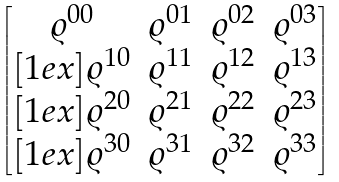<formula> <loc_0><loc_0><loc_500><loc_500>\begin{bmatrix} \varrho ^ { 0 0 } & \varrho ^ { 0 1 } & \varrho ^ { 0 2 } & \varrho ^ { 0 3 } \\ [ 1 e x ] \varrho ^ { 1 0 } & \varrho ^ { 1 1 } & \varrho ^ { 1 2 } & \varrho ^ { 1 3 } \\ [ 1 e x ] \varrho ^ { 2 0 } & \varrho ^ { 2 1 } & \varrho ^ { 2 2 } & \varrho ^ { 2 3 } \\ [ 1 e x ] \varrho ^ { 3 0 } & \varrho ^ { 3 1 } & \varrho ^ { 3 2 } & \varrho ^ { 3 3 } \end{bmatrix}</formula> 